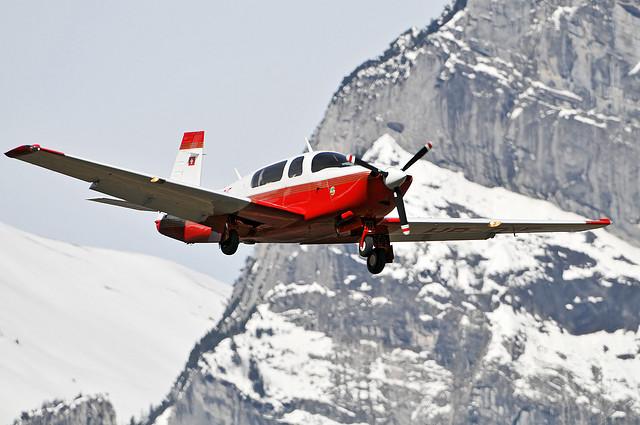What color is the plane?
Answer briefly. Red and white. What type of plane is this?
Quick response, please. Propeller. Are the mountains high?
Keep it brief. Yes. 